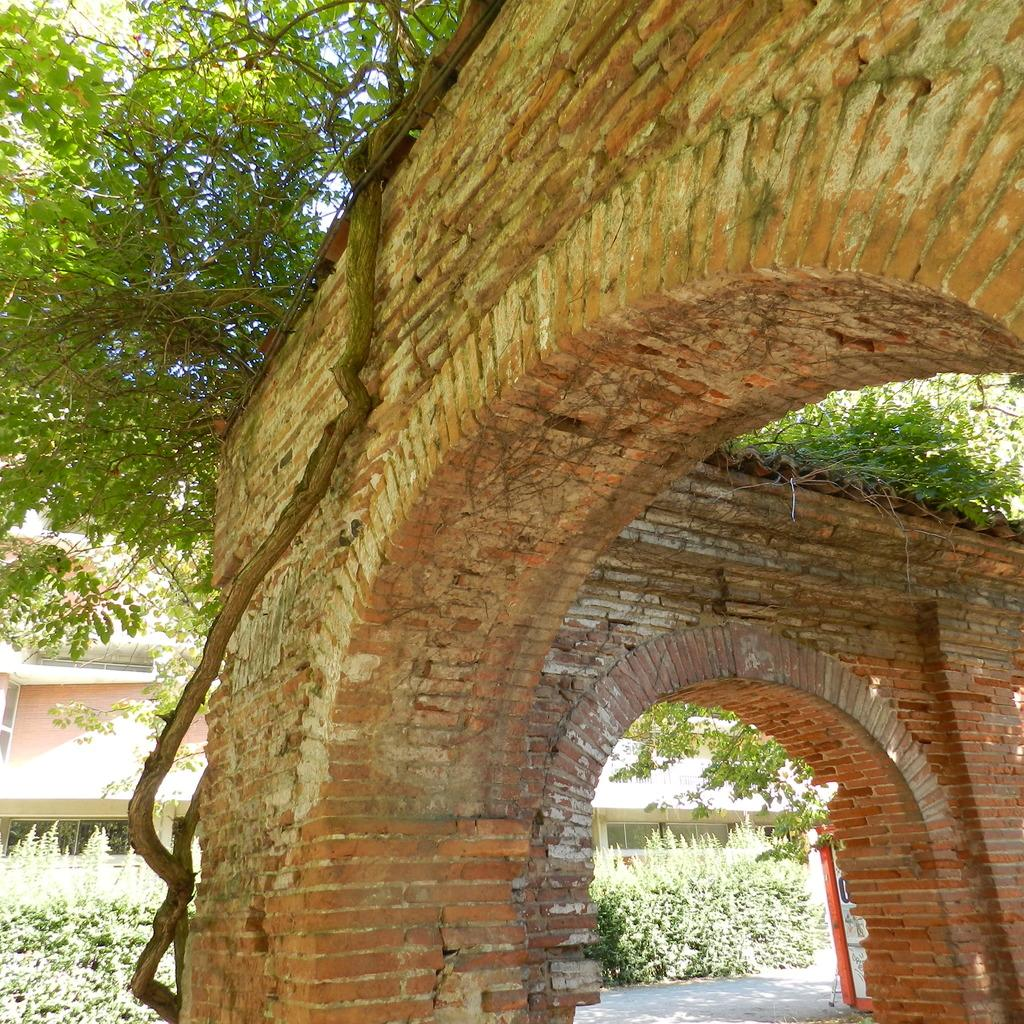What is the main structure visible in the image? There is a wall in the image. What can be seen behind the wall? There are trees, plants, and a house behind the wall. What type of doctor is attending to the patient in the image? There is no doctor or patient present in the image; it only features a wall, trees, plants, and a house. 